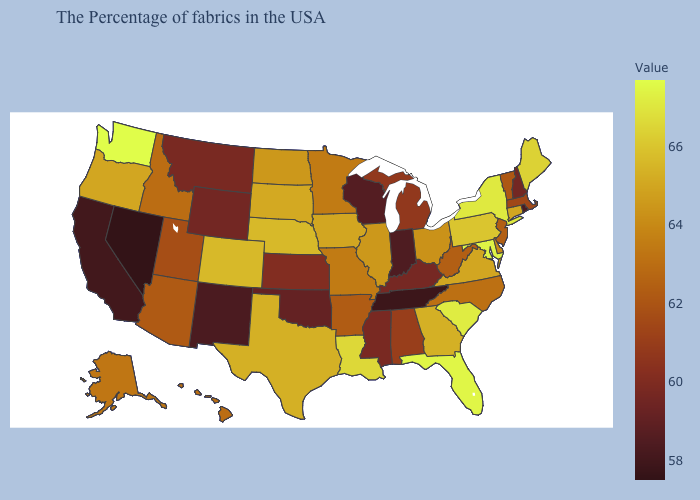Among the states that border Rhode Island , which have the highest value?
Answer briefly. Connecticut. Among the states that border Colorado , which have the highest value?
Short answer required. Nebraska. Which states have the lowest value in the USA?
Quick response, please. Nevada. Does South Dakota have a lower value than California?
Answer briefly. No. Does New York have the highest value in the Northeast?
Concise answer only. Yes. Among the states that border Idaho , which have the lowest value?
Short answer required. Nevada. Does Nebraska have the highest value in the MidWest?
Give a very brief answer. Yes. Is the legend a continuous bar?
Be succinct. Yes. Does Washington have the highest value in the USA?
Concise answer only. Yes. 